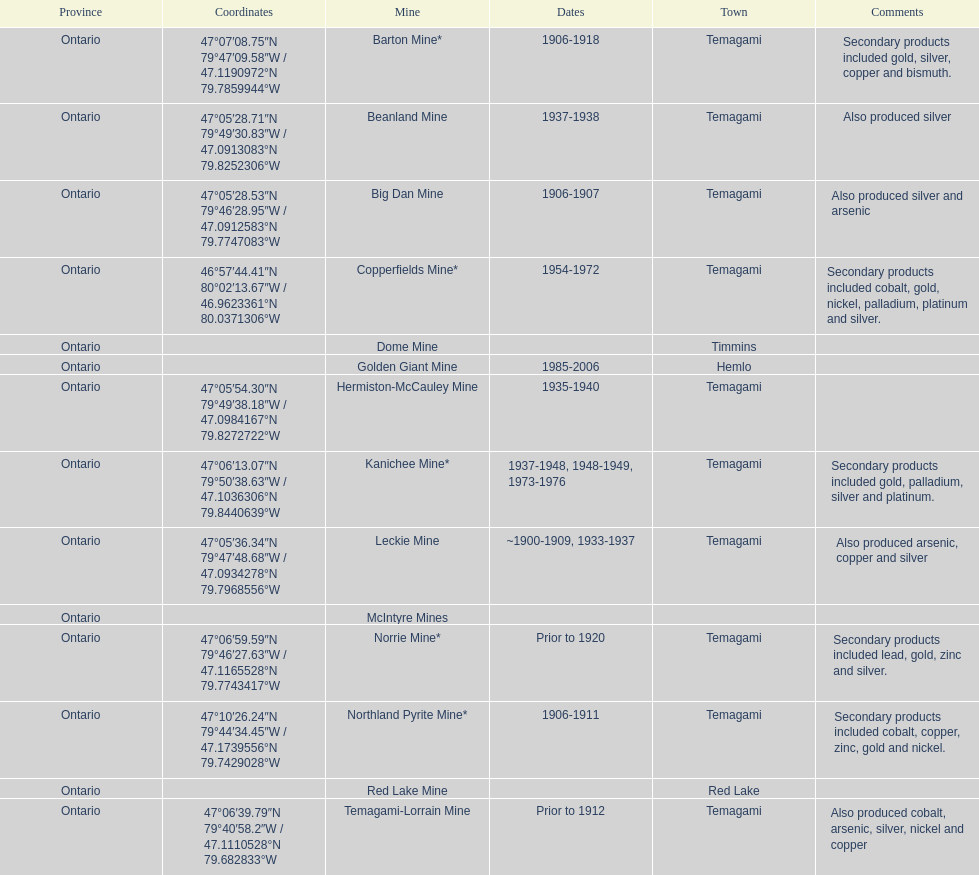Where can bismuth be found in a mine? Barton Mine. 